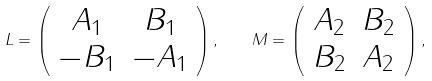Convert formula to latex. <formula><loc_0><loc_0><loc_500><loc_500>L = \left ( \begin{array} { c c } A _ { 1 } & B _ { 1 } \\ - B _ { 1 } & - A _ { 1 } \end{array} \right ) , \quad M = \left ( \begin{array} { c c } A _ { 2 } & B _ { 2 } \\ B _ { 2 } & A _ { 2 } \end{array} \right ) ,</formula> 